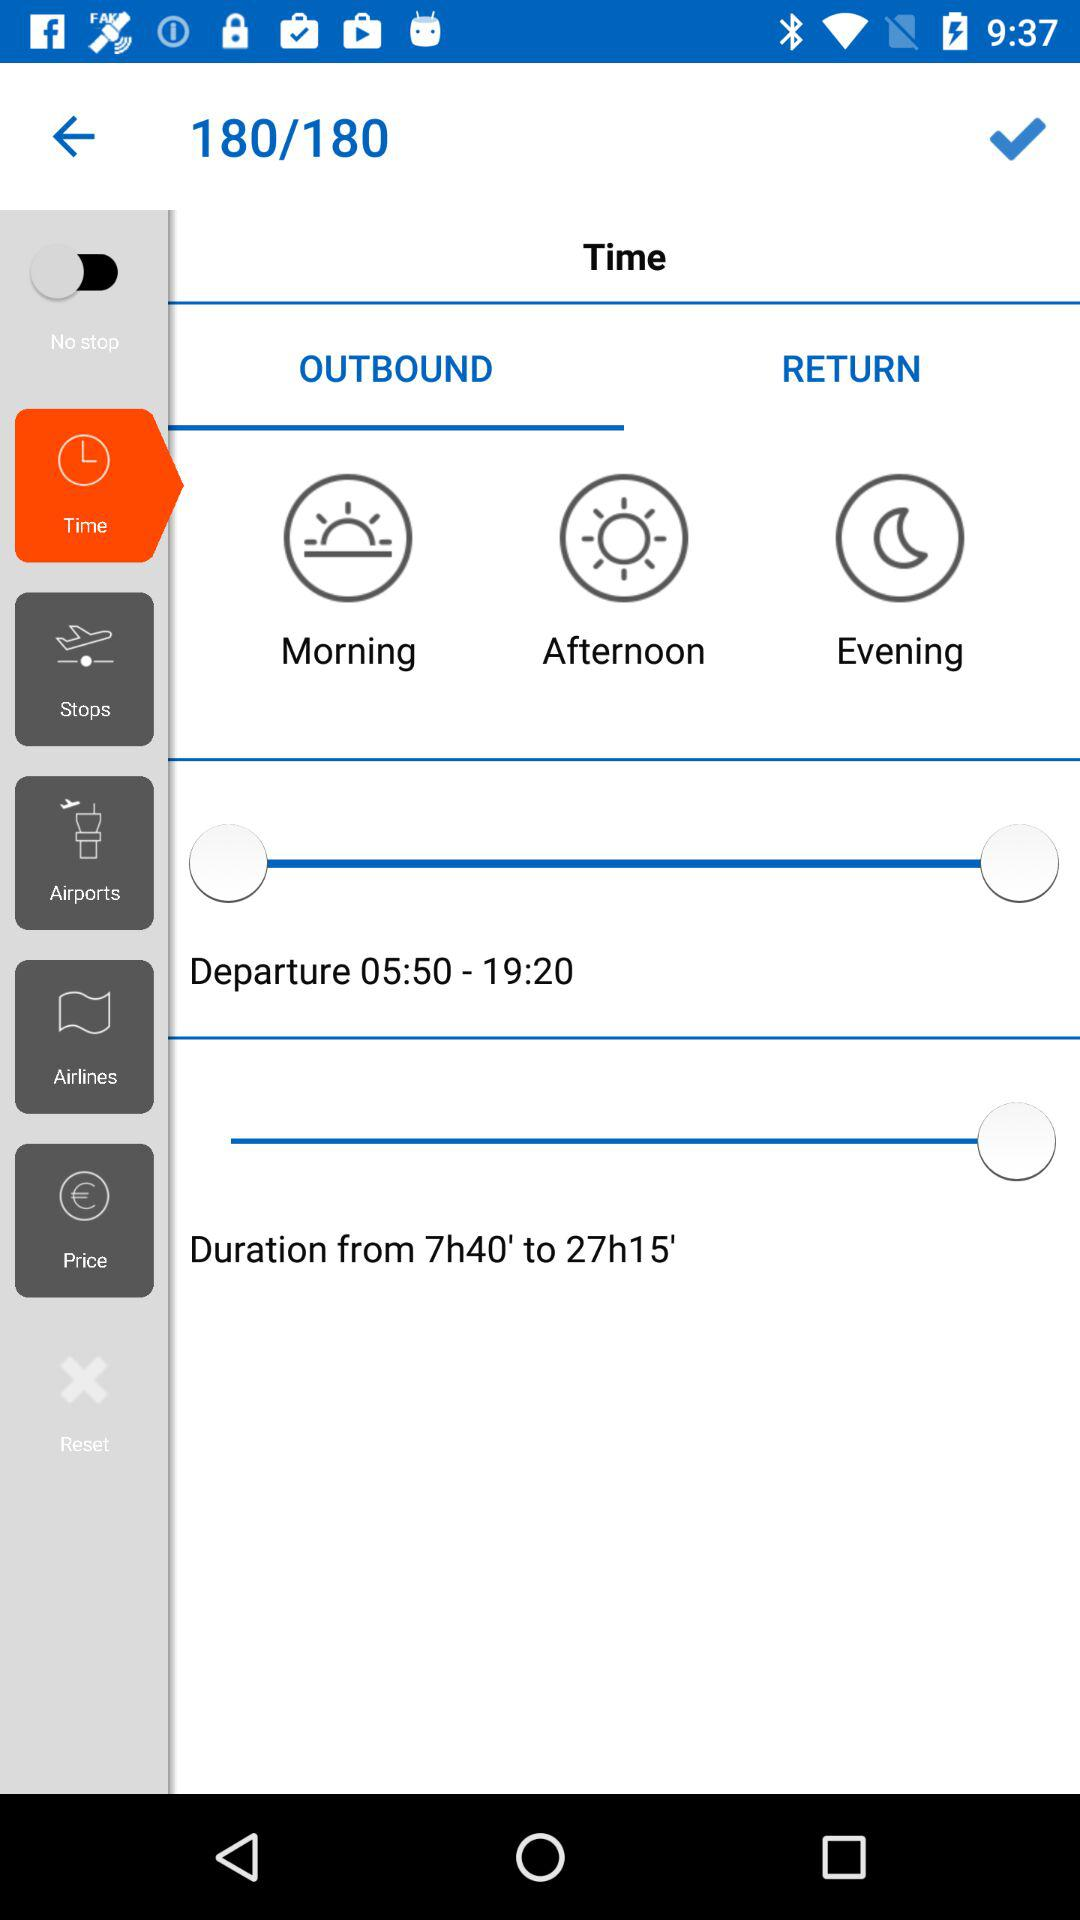What is the status of "No stop"? The status is "off". 